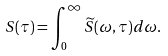Convert formula to latex. <formula><loc_0><loc_0><loc_500><loc_500>S ( \tau ) = \int _ { 0 } ^ { \infty } \widetilde { S } ( \omega , \tau ) d \omega .</formula> 